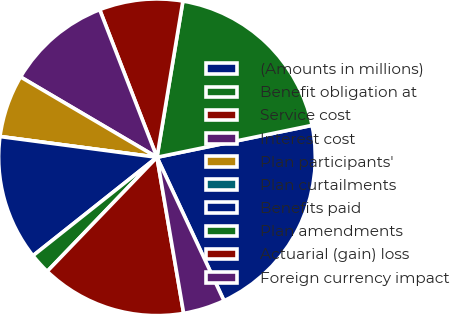Convert chart. <chart><loc_0><loc_0><loc_500><loc_500><pie_chart><fcel>(Amounts in millions)<fcel>Benefit obligation at<fcel>Service cost<fcel>Interest cost<fcel>Plan participants'<fcel>Plan curtailments<fcel>Benefits paid<fcel>Plan amendments<fcel>Actuarial (gain) loss<fcel>Foreign currency impact<nl><fcel>21.28%<fcel>19.15%<fcel>8.51%<fcel>10.64%<fcel>6.38%<fcel>0.0%<fcel>12.77%<fcel>2.13%<fcel>14.89%<fcel>4.26%<nl></chart> 